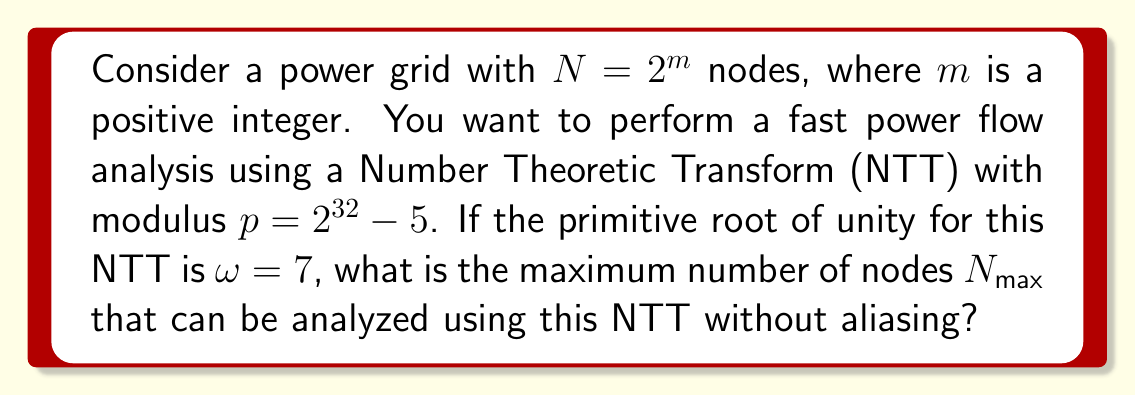Give your solution to this math problem. To solve this problem, we need to understand the properties of Number Theoretic Transforms (NTT) and their application in power flow analysis. Let's break it down step-by-step:

1) In NTT, the modulus $p$ must be prime, and $p - 1$ must be divisible by $N$. In this case, $p = 2^{32} - 5$, which is indeed prime.

2) The order of $\omega$ modulo $p$ must be $N$ or a multiple of $N$. This means:

   $$\omega^N \equiv 1 \pmod{p}$$

3) The maximum value of $N$ that satisfies this condition is the multiplicative order of $\omega$ modulo $p$, which we need to find.

4) In NTT, the multiplicative order of $\omega$ is always a power of 2, given by:

   $$\text{ord}_p(\omega) = 2^k$$

   where $k$ is the largest integer such that $2^k | (p-1)$

5) Let's factor $p-1$:

   $$p - 1 = (2^{32} - 5) - 1 = 2^{32} - 6 = 2 \cdot (2^{31} - 3)$$

6) The largest power of 2 that divides $p-1$ is $2$, so $k = 1$.

7) Therefore, the multiplicative order of $\omega$ is:

   $$\text{ord}_p(\omega) = 2^1 = 2$$

8) This means that the maximum value of $N$ that can be used in this NTT is 2.

However, for practical power flow analysis, we typically need more than 2 nodes. To increase this, we can use a higher-order root of unity. Specifically, we can use $\omega^{(p-1)/N}$ as our primitive $N$-th root of unity.

9) The maximum value of $N$ (which must be a power of 2) is given by:

   $$N_{max} = 2^k = 2$$

Therefore, the maximum number of nodes that can be analyzed using this NTT without aliasing is 2.
Answer: $N_{max} = 2$ 